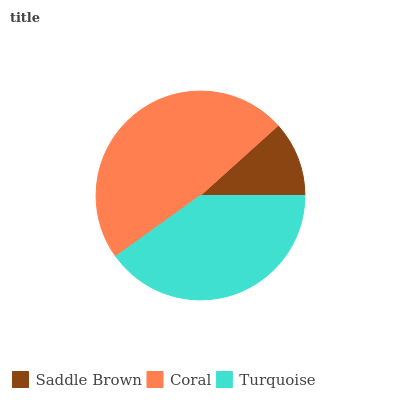Is Saddle Brown the minimum?
Answer yes or no. Yes. Is Coral the maximum?
Answer yes or no. Yes. Is Turquoise the minimum?
Answer yes or no. No. Is Turquoise the maximum?
Answer yes or no. No. Is Coral greater than Turquoise?
Answer yes or no. Yes. Is Turquoise less than Coral?
Answer yes or no. Yes. Is Turquoise greater than Coral?
Answer yes or no. No. Is Coral less than Turquoise?
Answer yes or no. No. Is Turquoise the high median?
Answer yes or no. Yes. Is Turquoise the low median?
Answer yes or no. Yes. Is Coral the high median?
Answer yes or no. No. Is Coral the low median?
Answer yes or no. No. 